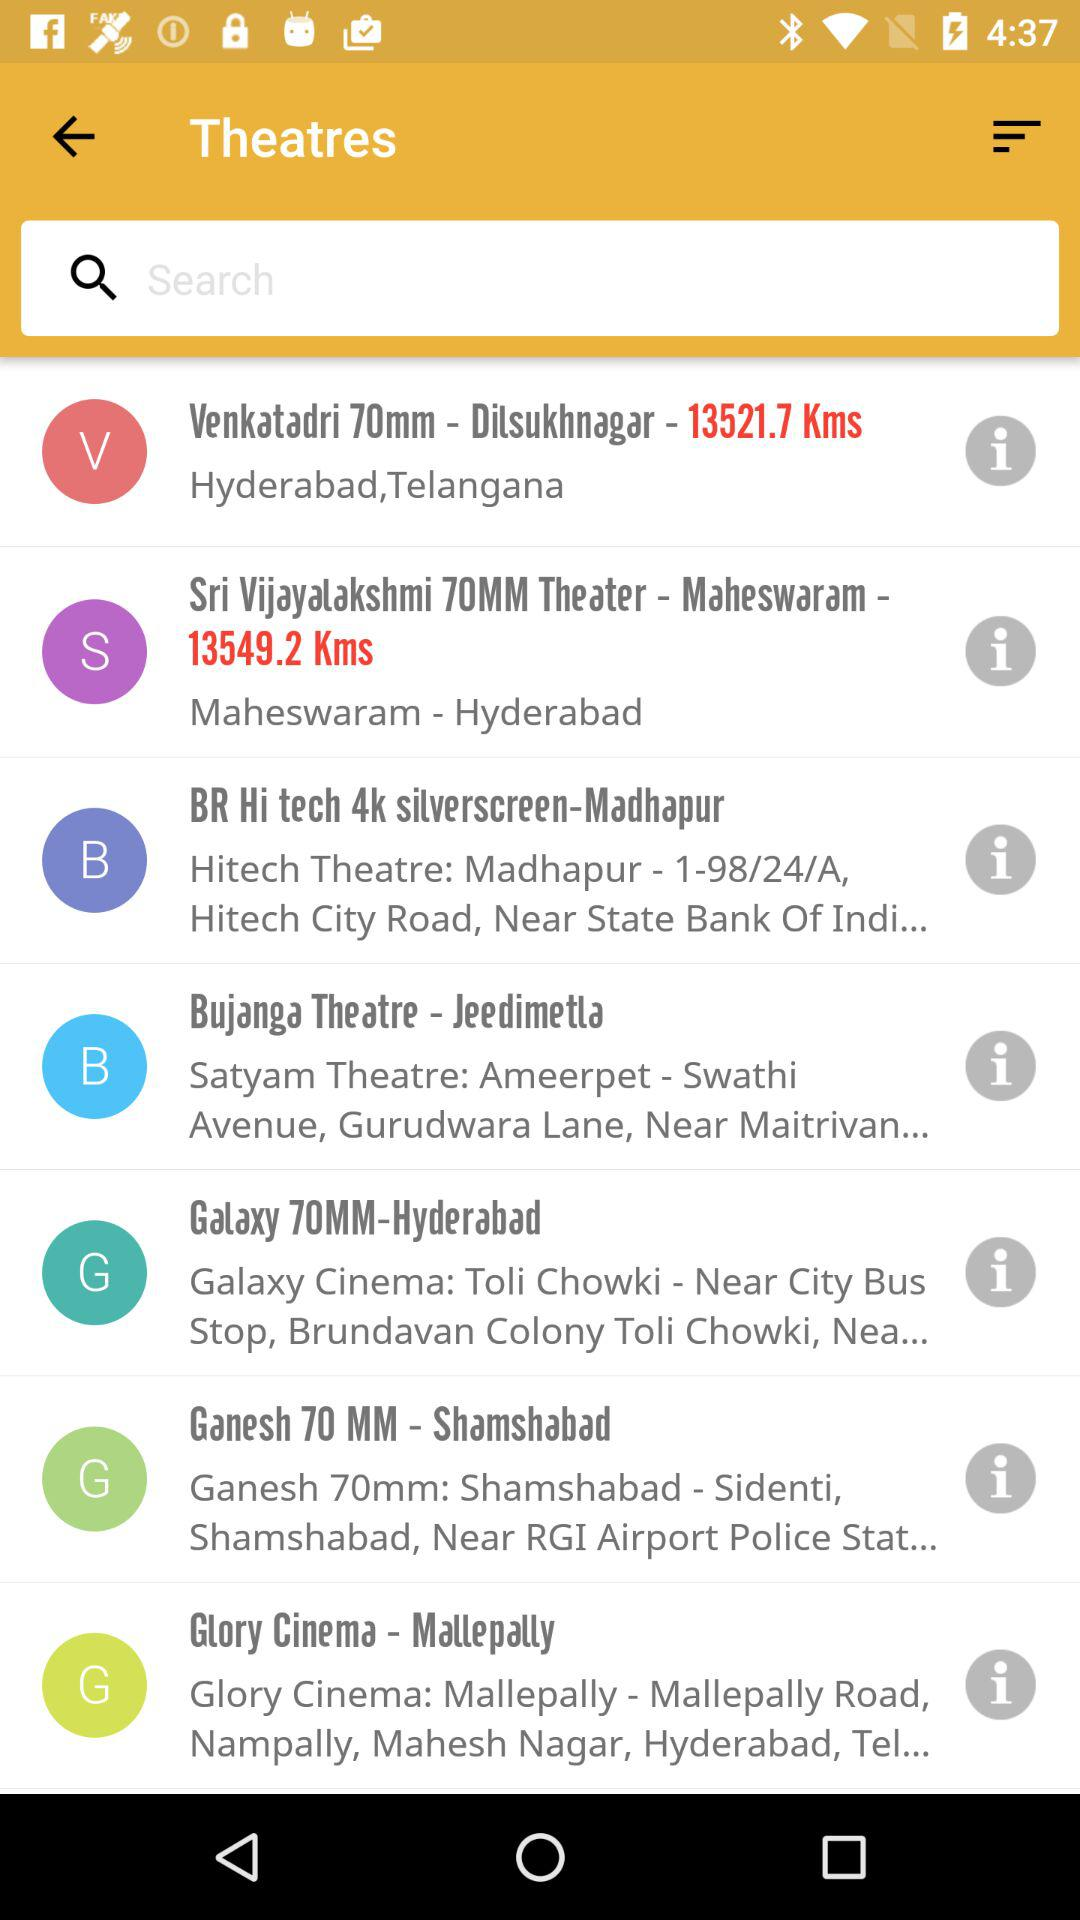How far is the "Sri Vijayalakshmi 70MM Theater"? The "Sri Vijayalakshmi 70MM Theater" is 13549.2 km away. 